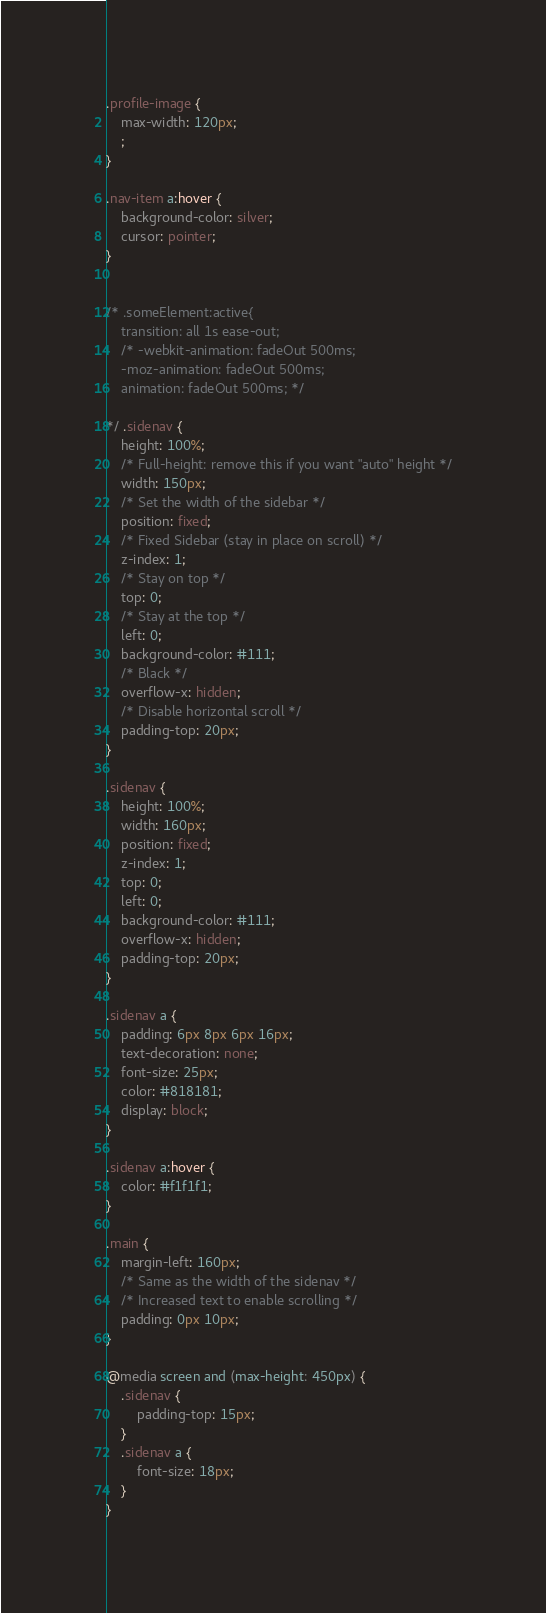<code> <loc_0><loc_0><loc_500><loc_500><_CSS_>.profile-image {
    max-width: 120px;
    ;
}

.nav-item a:hover {
    background-color: silver;
    cursor: pointer;
}


/* .someElement:active{
    transition: all 1s ease-out;
    /* -webkit-animation: fadeOut 500ms;
    -moz-animation: fadeOut 500ms;
    animation: fadeOut 500ms; */

*/ .sidenav {
    height: 100%;
    /* Full-height: remove this if you want "auto" height */
    width: 150px;
    /* Set the width of the sidebar */
    position: fixed;
    /* Fixed Sidebar (stay in place on scroll) */
    z-index: 1;
    /* Stay on top */
    top: 0;
    /* Stay at the top */
    left: 0;
    background-color: #111;
    /* Black */
    overflow-x: hidden;
    /* Disable horizontal scroll */
    padding-top: 20px;
}

.sidenav {
    height: 100%;
    width: 160px;
    position: fixed;
    z-index: 1;
    top: 0;
    left: 0;
    background-color: #111;
    overflow-x: hidden;
    padding-top: 20px;
}

.sidenav a {
    padding: 6px 8px 6px 16px;
    text-decoration: none;
    font-size: 25px;
    color: #818181;
    display: block;
}

.sidenav a:hover {
    color: #f1f1f1;
}

.main {
    margin-left: 160px;
    /* Same as the width of the sidenav */
    /* Increased text to enable scrolling */
    padding: 0px 10px;
}

@media screen and (max-height: 450px) {
    .sidenav {
        padding-top: 15px;
    }
    .sidenav a {
        font-size: 18px;
    }
}</code> 